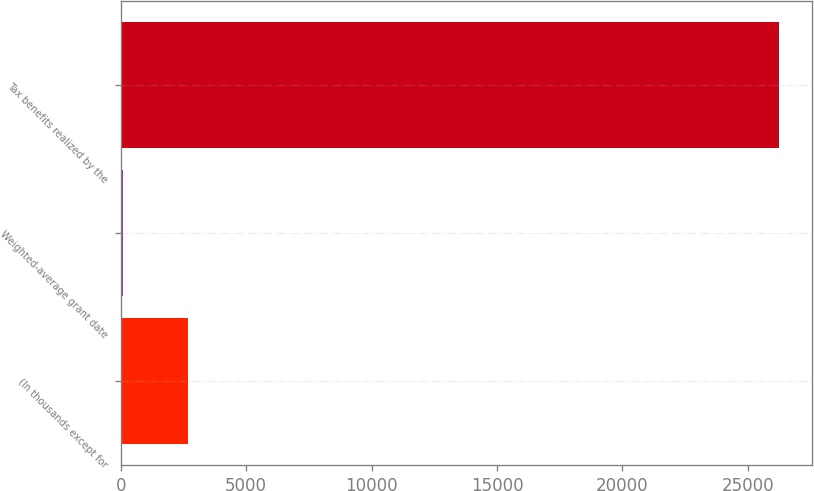<chart> <loc_0><loc_0><loc_500><loc_500><bar_chart><fcel>(In thousands except for<fcel>Weighted-average grant date<fcel>Tax benefits realized by the<nl><fcel>2692.03<fcel>74.48<fcel>26250<nl></chart> 